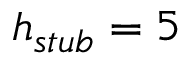<formula> <loc_0><loc_0><loc_500><loc_500>h _ { s t u b } = 5</formula> 